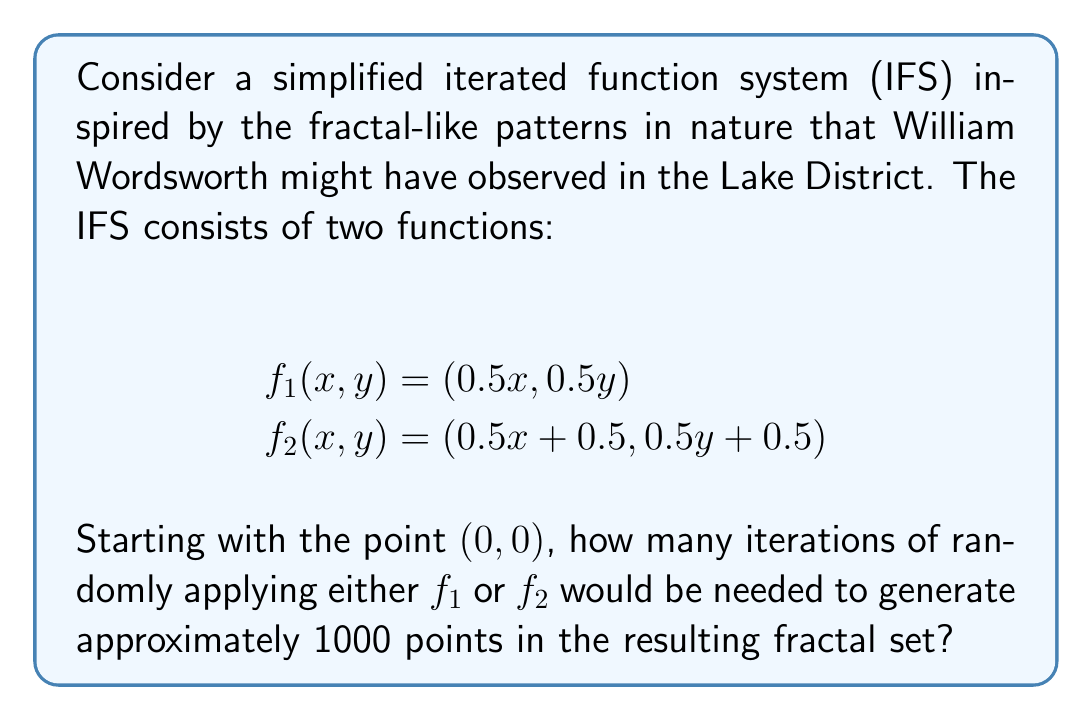Give your solution to this math problem. To solve this problem, we need to understand the concept of iterated function systems and how they generate fractal patterns. Let's break it down step-by-step:

1) An iterated function system (IFS) is a method of constructing fractals by repeatedly applying a set of functions to an initial point.

2) In this case, we have two functions:
   $f_1(x, y) = (0.5x, 0.5y)$
   $f_2(x, y) = (0.5x + 0.5, 0.5y + 0.5)$

3) Each iteration generates a new point by randomly choosing and applying either $f_1$ or $f_2$ to the previous point.

4) The number of points generated after $n$ iterations is equal to $2^n$, because at each step, we have 2 choices (either $f_1$ or $f_2$), and this compounds over $n$ iterations.

5) We need to find $n$ such that $2^n \approx 1000$.

6) We can use logarithms to solve this:

   $2^n = 1000$
   $n \log 2 = \log 1000$
   $n = \frac{\log 1000}{\log 2}$

7) Using a calculator or computer:
   $n = \frac{\log 1000}{\log 2} \approx 9.97$

8) Since we need an integer number of iterations, we round up to the nearest whole number.

Therefore, 10 iterations would be needed to generate approximately 1000 points in the fractal set.
Answer: 10 iterations 